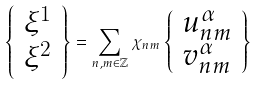<formula> <loc_0><loc_0><loc_500><loc_500>\left \{ \begin{array} { l l } \xi ^ { 1 } \\ \xi ^ { 2 } \end{array} \right \} = \sum _ { n , m \in \mathbb { Z } } \chi _ { n m } \left \{ \begin{array} { l l } u ^ { \alpha } _ { n m } \\ v ^ { \alpha } _ { n m } \end{array} \right \}</formula> 